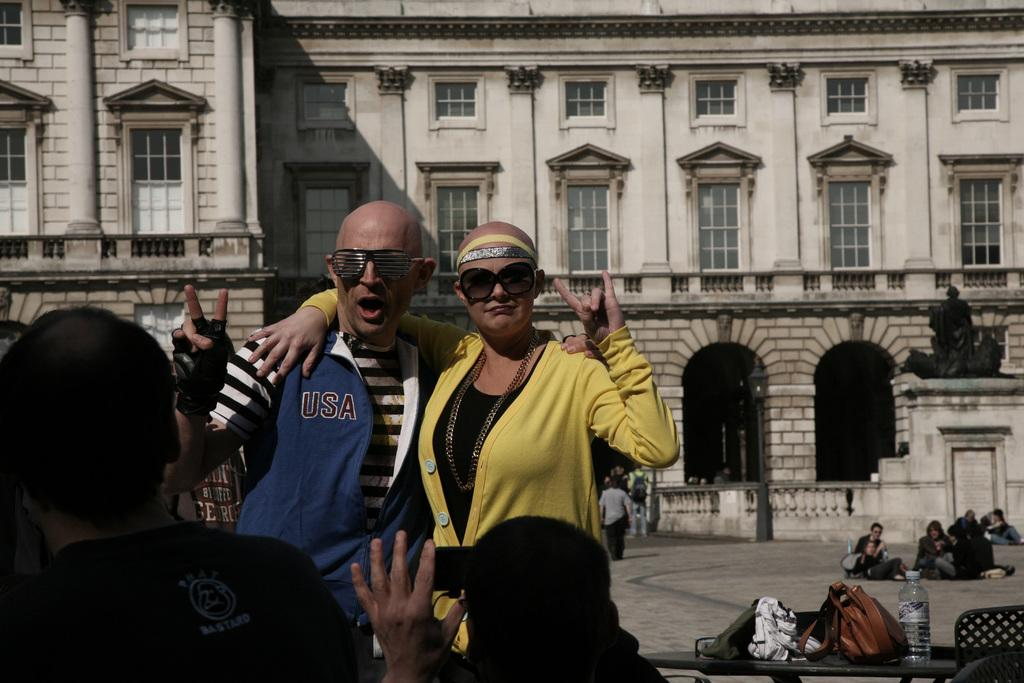What type of windows does the building have? The building has glass windows. What are the two people in front of the building doing? The two people are giving stills in front of the building. What can be seen in the background of the image? There is a statue and people visible in the background. What objects are on the table in the image? There is a bag and a bottle on the table. What type of discovery was made near the hydrant in the image? There is no hydrant present in the image, so no discovery can be associated with it. Can you tell me how many times the person in the image refers to themselves? There is no person in the image who is speaking or referring to themselves, so this information cannot be determined. 